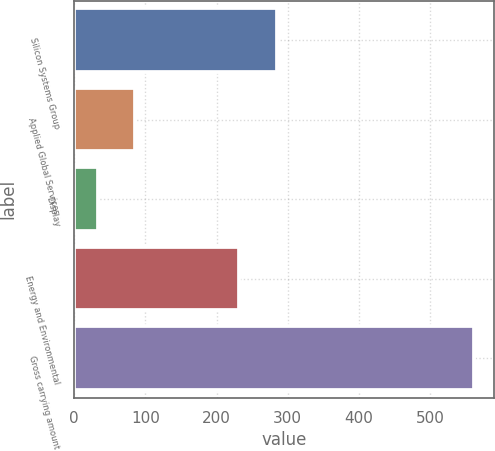<chart> <loc_0><loc_0><loc_500><loc_500><bar_chart><fcel>Silicon Systems Group<fcel>Applied Global Services<fcel>Display<fcel>Energy and Environmental<fcel>Gross carrying amount<nl><fcel>284.8<fcel>85.8<fcel>33<fcel>232<fcel>561<nl></chart> 